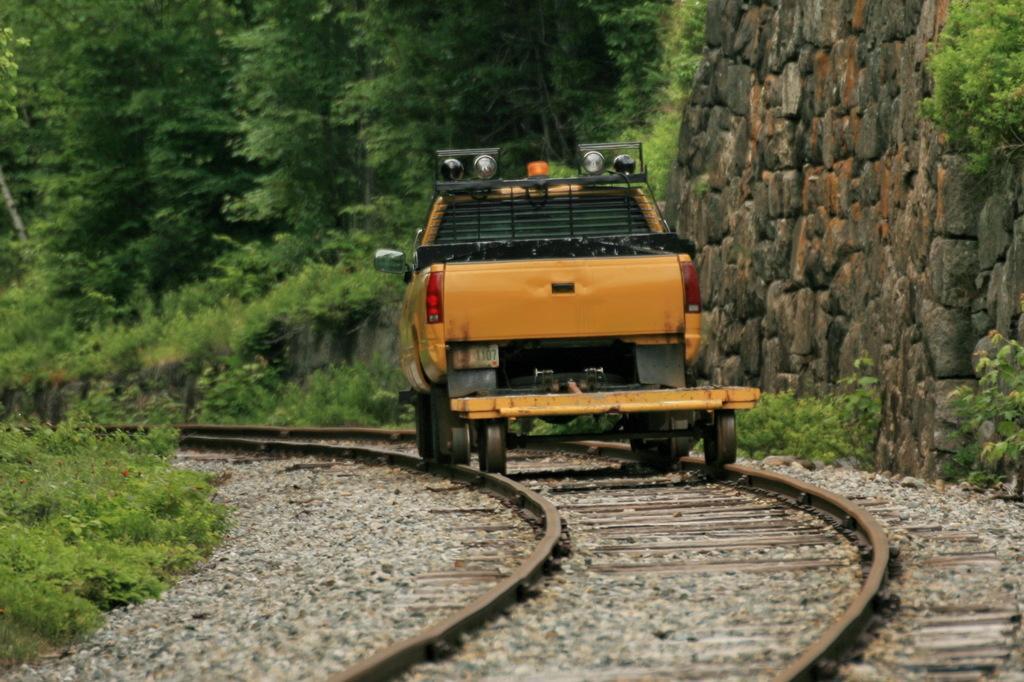How would you summarize this image in a sentence or two? In this image we can see a vehicle on a track. On the right side there is a wall and plants. We can see a group of trees behind the vehicle. On the left side, we can see grass and plants. At the bottom we can see the track and stones. 